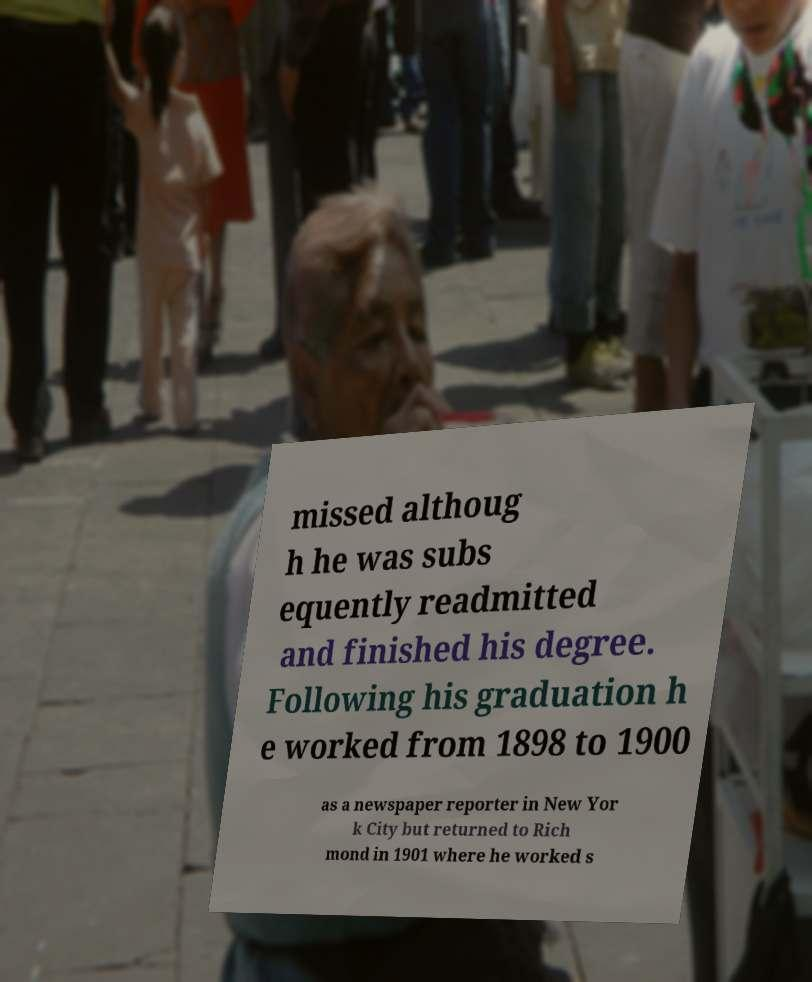Could you extract and type out the text from this image? missed althoug h he was subs equently readmitted and finished his degree. Following his graduation h e worked from 1898 to 1900 as a newspaper reporter in New Yor k City but returned to Rich mond in 1901 where he worked s 